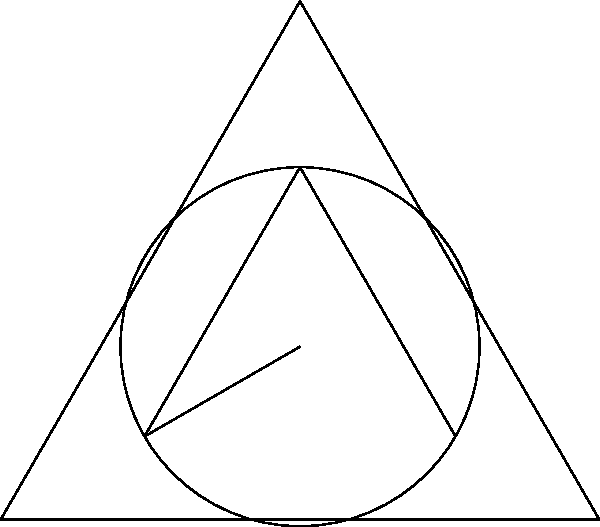In the context of geometric peace symbols, consider an equilateral triangle inscribing a circle with three lines inside forming a peace symbol. If the triangle has a side length of 1 unit, what is the ratio of the area of the circle to the area of the triangle, rounded to two decimal places? Let's approach this step-by-step:

1) First, we need to calculate the area of the equilateral triangle:
   - The area of an equilateral triangle with side length $s$ is given by $A_t = \frac{\sqrt{3}}{4}s^2$
   - With $s = 1$, $A_t = \frac{\sqrt{3}}{4} \approx 0.433$

2) Next, we need to find the radius of the inscribed circle:
   - The radius of an inscribed circle in an equilateral triangle is given by $r = \frac{s}{2\sqrt{3}}$
   - With $s = 1$, $r = \frac{1}{2\sqrt{3}} \approx 0.289$

3) Now we can calculate the area of the circle:
   - The area of a circle is given by $A_c = \pi r^2$
   - $A_c = \pi (\frac{1}{2\sqrt{3}})^2 = \frac{\pi}{12} \approx 0.262$

4) Finally, we can calculate the ratio:
   - Ratio = $\frac{A_c}{A_t} = \frac{\frac{\pi}{12}}{\frac{\sqrt{3}}{4}} = \frac{\pi}{3\sqrt{3}} \approx 0.605$

5) Rounding to two decimal places: 0.60

This ratio demonstrates the balance between the circular peace symbol and the triangular structure, symbolizing the harmony and proportion in peaceful resolutions.
Answer: 0.60 